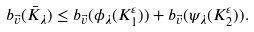Convert formula to latex. <formula><loc_0><loc_0><loc_500><loc_500>b _ { \vec { v } } ( \bar { K } _ { \lambda } ) \leq b _ { \vec { v } } ( \phi _ { \lambda } ( K ^ { \varepsilon } _ { 1 } ) ) + b _ { \vec { v } } ( \psi _ { \lambda } ( K ^ { \varepsilon } _ { 2 } ) ) .</formula> 